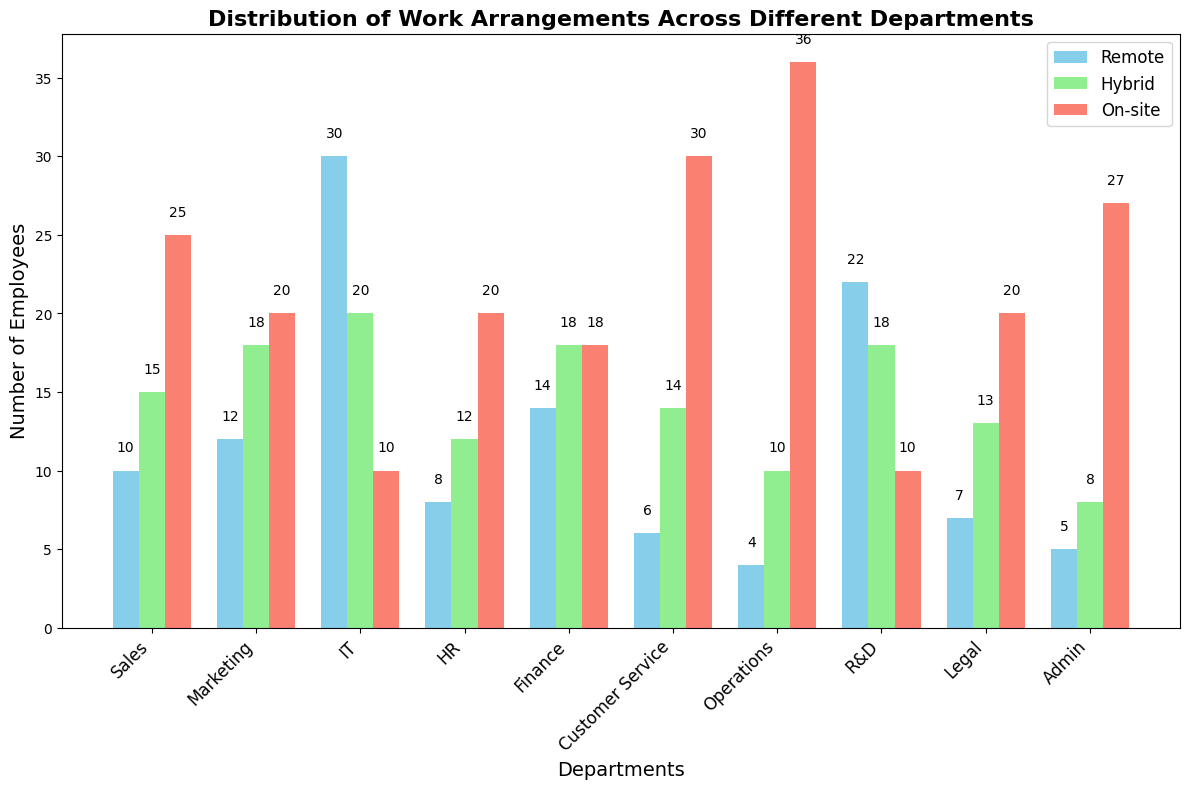Which department has the highest number of On-site employees? The Operations department has the tallest salmon-colored bar, representing On-site employees, indicating the highest count.
Answer: Operations How many more Remote employees are there in the IT department compared to the Operations department? The IT department has 30 Remote employees and the Operations department has 4. The difference is 30 - 4 = 26.
Answer: 26 What is the total number of employees in the R&D department across all work arrangements? Summing the count of Remote (22), Hybrid (18), and On-site (10) employees in the R&D department: 22 + 18 + 10 = 50.
Answer: 50 Which work arrangement is the least common in the Sales department? The Sales department has 10 Remote employees (skyblue), 15 Hybrid employees (lightgreen), and 25 On-site employees (salmon). The smallest number is Remote with 10.
Answer: Remote Compare the number of Hybrid employees in Marketing and Customer Service. Which department has more, and by how much? Marketing has 18 Hybrid employees, and Customer Service has 14. The difference is 18 - 14 = 4.
Answer: Marketing by 4 Across all departments, which work arrangement has the highest count of employees? By visually summing the bars, On-site (salmon) generally appears higher across most departments, indicating the highest count.
Answer: On-site In the HR department, what's the average number of employees per work arrangement? The HR department has 8 Remote, 12 Hybrid, and 20 On-site employees. The average is (8 + 12 + 20) / 3 = 40 / 3 ≈ 13.33.
Answer: ~13.33 Which department has an equal number of Hybrid and On-site employees? The Finance department has 18 Hybrid and 18 On-site employees, both represented by bars of the same height.
Answer: Finance What is the total number of employees working remotely across all departments? Adding each department's Remote employees: 10 + 12 + 30 + 8 + 14 + 6 + 4 + 22 + 7 + 5 = 118.
Answer: 118 How many more employees work On-site in the Admin department compared to Hybrid? The Admin department has 27 On-site (salmon) and 8 Hybrid (lightgreen) employees. The difference is 27 - 8 = 19.
Answer: 19 